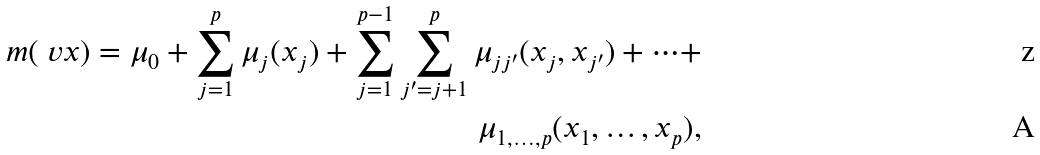Convert formula to latex. <formula><loc_0><loc_0><loc_500><loc_500>m ( \ v x ) = \mu _ { 0 } + \sum _ { j = 1 } ^ { p } \mu _ { j } ( x _ { j } ) + \sum _ { j = 1 } ^ { p - 1 } \sum _ { j ^ { \prime } = j + 1 } ^ { p } \mu _ { j j ^ { \prime } } ( x _ { j } , x _ { j ^ { \prime } } ) + \dots + \\ \mu _ { 1 , \dots , p } ( x _ { 1 } , \dots , x _ { p } ) ,</formula> 